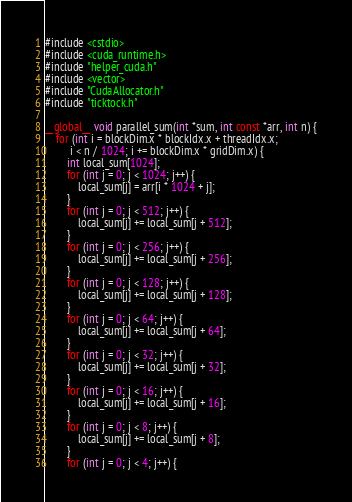<code> <loc_0><loc_0><loc_500><loc_500><_Cuda_>#include <cstdio>
#include <cuda_runtime.h>
#include "helper_cuda.h"
#include <vector>
#include "CudaAllocator.h"
#include "ticktock.h"

__global__ void parallel_sum(int *sum, int const *arr, int n) {
    for (int i = blockDim.x * blockIdx.x + threadIdx.x;
         i < n / 1024; i += blockDim.x * gridDim.x) {
        int local_sum[1024];
        for (int j = 0; j < 1024; j++) {
            local_sum[j] = arr[i * 1024 + j];
        }
        for (int j = 0; j < 512; j++) {
            local_sum[j] += local_sum[j + 512];
        }
        for (int j = 0; j < 256; j++) {
            local_sum[j] += local_sum[j + 256];
        }
        for (int j = 0; j < 128; j++) {
            local_sum[j] += local_sum[j + 128];
        }
        for (int j = 0; j < 64; j++) {
            local_sum[j] += local_sum[j + 64];
        }
        for (int j = 0; j < 32; j++) {
            local_sum[j] += local_sum[j + 32];
        }
        for (int j = 0; j < 16; j++) {
            local_sum[j] += local_sum[j + 16];
        }
        for (int j = 0; j < 8; j++) {
            local_sum[j] += local_sum[j + 8];
        }
        for (int j = 0; j < 4; j++) {</code> 